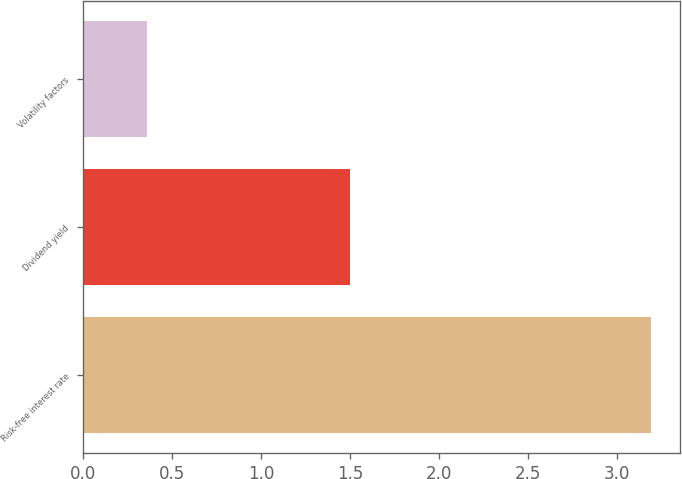Convert chart to OTSL. <chart><loc_0><loc_0><loc_500><loc_500><bar_chart><fcel>Risk-free interest rate<fcel>Dividend yield<fcel>Volatility factors<nl><fcel>3.19<fcel>1.5<fcel>0.36<nl></chart> 